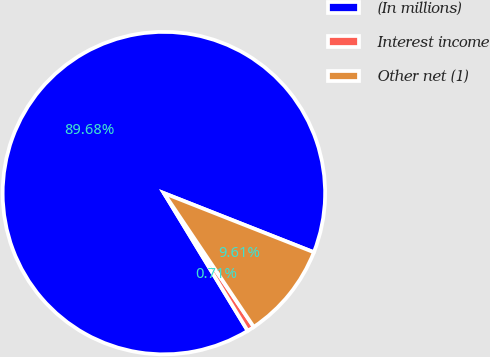Convert chart to OTSL. <chart><loc_0><loc_0><loc_500><loc_500><pie_chart><fcel>(In millions)<fcel>Interest income<fcel>Other net (1)<nl><fcel>89.68%<fcel>0.71%<fcel>9.61%<nl></chart> 